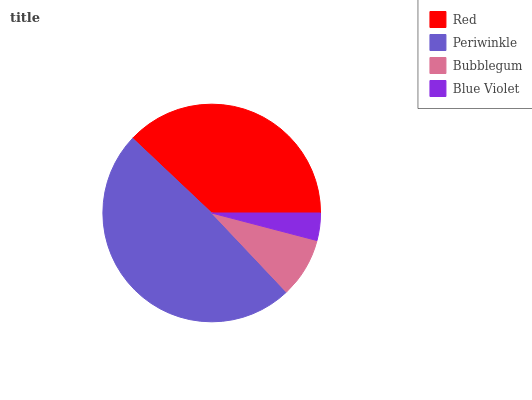Is Blue Violet the minimum?
Answer yes or no. Yes. Is Periwinkle the maximum?
Answer yes or no. Yes. Is Bubblegum the minimum?
Answer yes or no. No. Is Bubblegum the maximum?
Answer yes or no. No. Is Periwinkle greater than Bubblegum?
Answer yes or no. Yes. Is Bubblegum less than Periwinkle?
Answer yes or no. Yes. Is Bubblegum greater than Periwinkle?
Answer yes or no. No. Is Periwinkle less than Bubblegum?
Answer yes or no. No. Is Red the high median?
Answer yes or no. Yes. Is Bubblegum the low median?
Answer yes or no. Yes. Is Periwinkle the high median?
Answer yes or no. No. Is Blue Violet the low median?
Answer yes or no. No. 